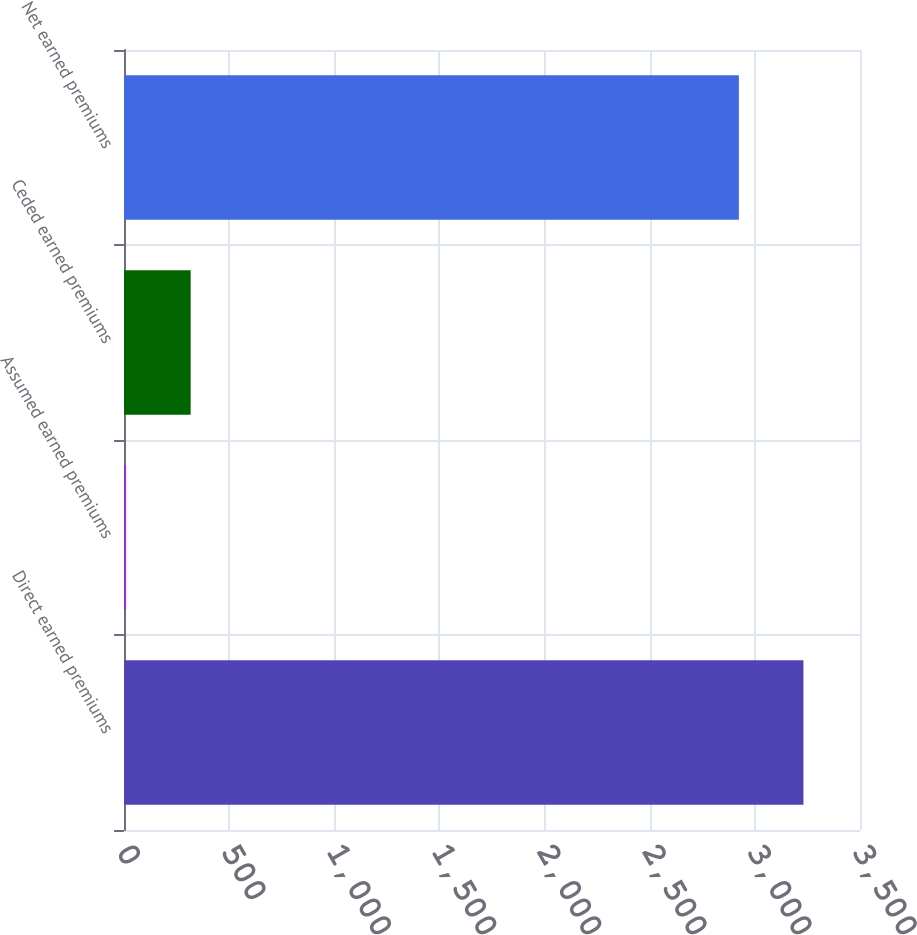<chart> <loc_0><loc_0><loc_500><loc_500><bar_chart><fcel>Direct earned premiums<fcel>Assumed earned premiums<fcel>Ceded earned premiums<fcel>Net earned premiums<nl><fcel>3231<fcel>10<fcel>317<fcel>2924<nl></chart> 